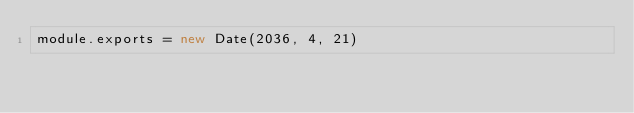Convert code to text. <code><loc_0><loc_0><loc_500><loc_500><_JavaScript_>module.exports = new Date(2036, 4, 21)
</code> 